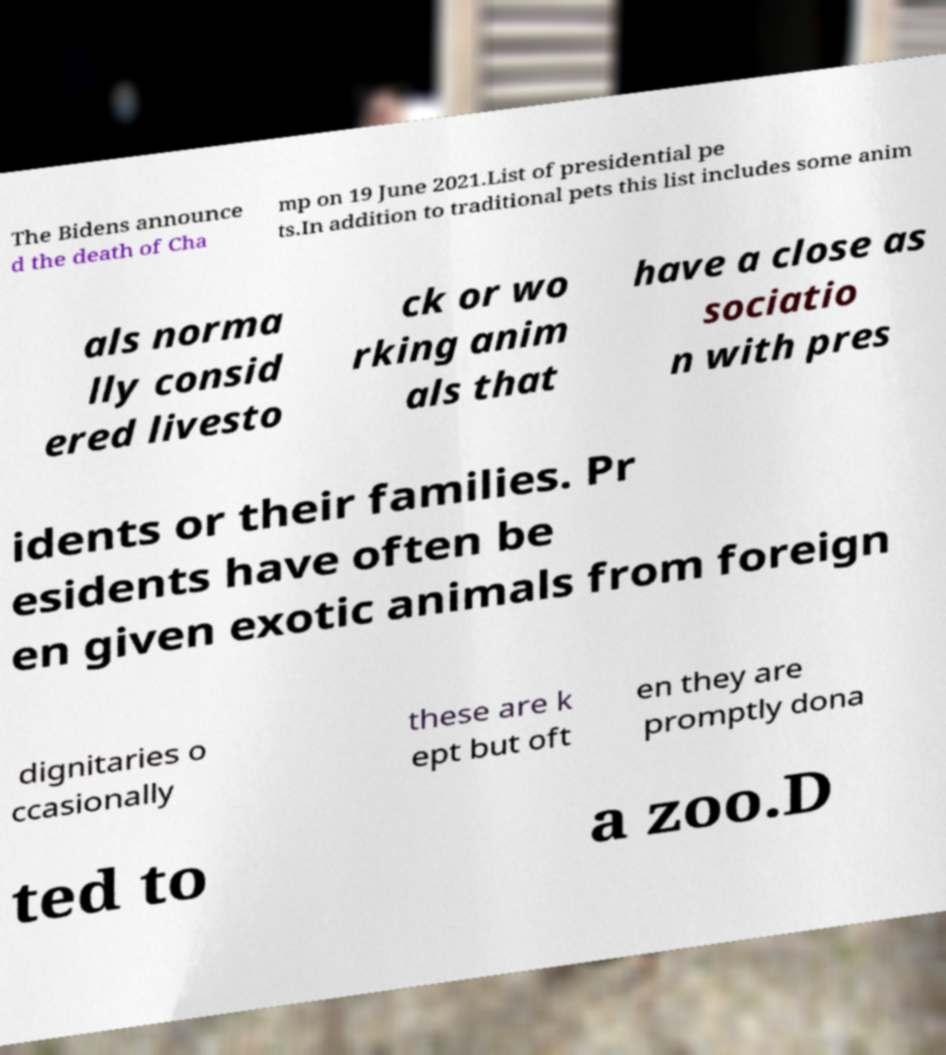I need the written content from this picture converted into text. Can you do that? The Bidens announce d the death of Cha mp on 19 June 2021.List of presidential pe ts.In addition to traditional pets this list includes some anim als norma lly consid ered livesto ck or wo rking anim als that have a close as sociatio n with pres idents or their families. Pr esidents have often be en given exotic animals from foreign dignitaries o ccasionally these are k ept but oft en they are promptly dona ted to a zoo.D 